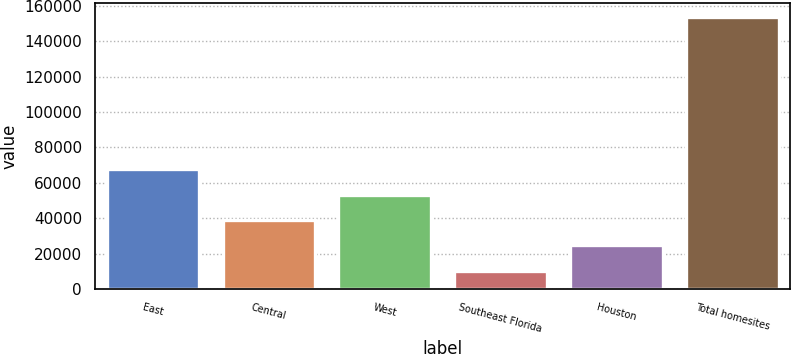<chart> <loc_0><loc_0><loc_500><loc_500><bar_chart><fcel>East<fcel>Central<fcel>West<fcel>Southeast Florida<fcel>Houston<fcel>Total homesites<nl><fcel>67722.2<fcel>39037.6<fcel>53379.9<fcel>10353<fcel>24695.3<fcel>153776<nl></chart> 